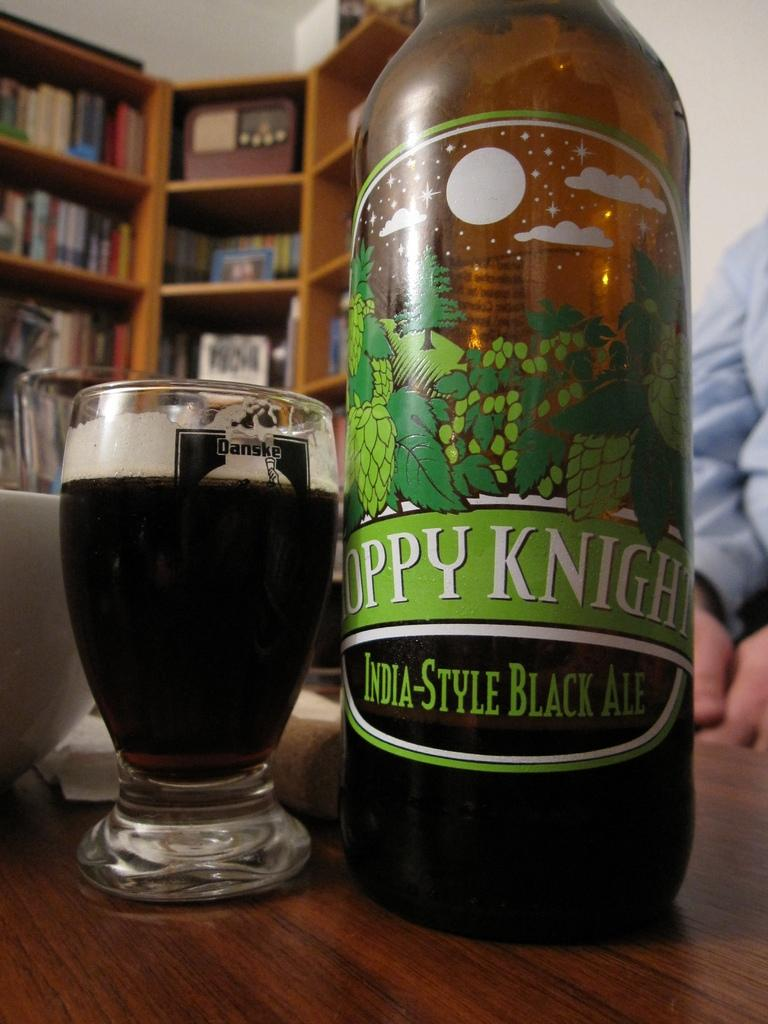<image>
Write a terse but informative summary of the picture. A bottle of India-style black ale with a full glass of beer. 